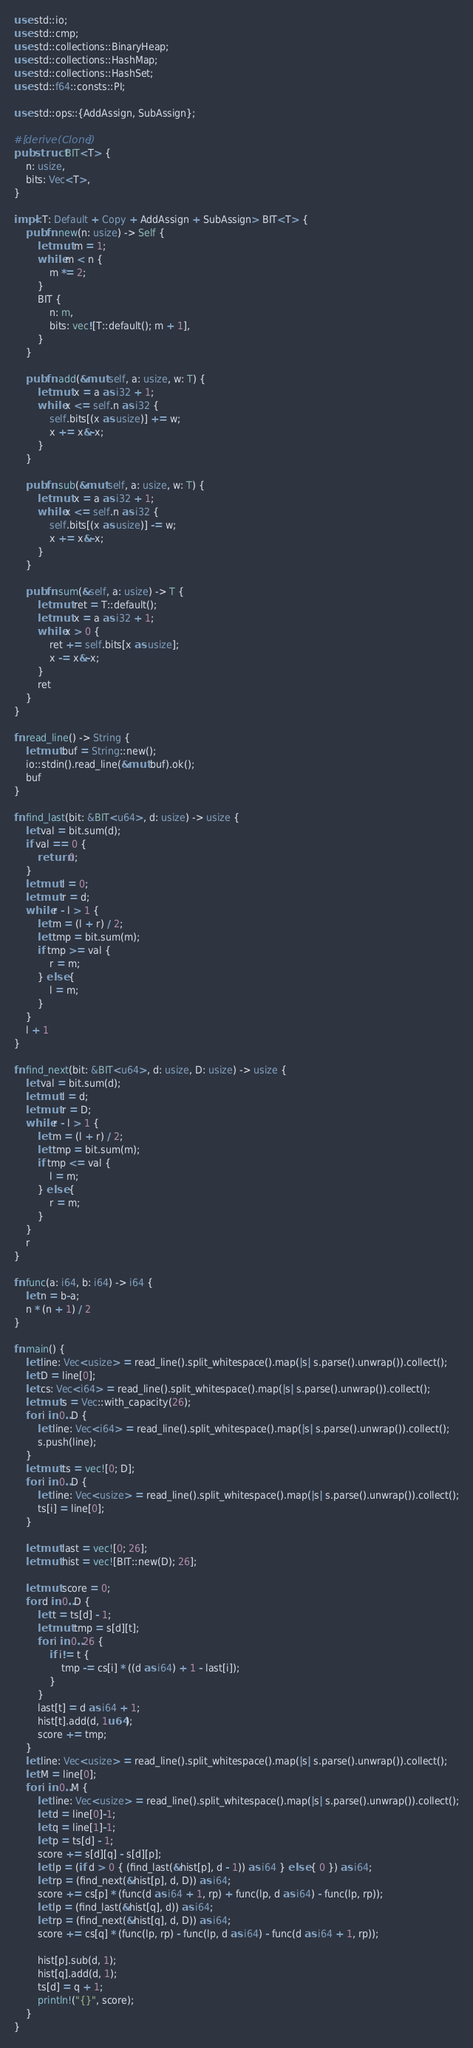<code> <loc_0><loc_0><loc_500><loc_500><_Rust_>use std::io;
use std::cmp;
use std::collections::BinaryHeap;
use std::collections::HashMap;
use std::collections::HashSet;
use std::f64::consts::PI;

use std::ops::{AddAssign, SubAssign};

#[derive(Clone)]
pub struct BIT<T> {
    n: usize,
    bits: Vec<T>,
}
 
impl<T: Default + Copy + AddAssign + SubAssign> BIT<T> {
    pub fn new(n: usize) -> Self {
        let mut m = 1;
        while m < n {
            m *= 2;
        }
        BIT {
            n: m,
            bits: vec![T::default(); m + 1],
        }
    }
 
    pub fn add(&mut self, a: usize, w: T) {
        let mut x = a as i32 + 1;
        while x <= self.n as i32 {
            self.bits[(x as usize)] += w;
            x += x&-x;
        }
    }
    
    pub fn sub(&mut self, a: usize, w: T) {
        let mut x = a as i32 + 1;
        while x <= self.n as i32 {
            self.bits[(x as usize)] -= w;
            x += x&-x;
        }
    }
 
    pub fn sum(&self, a: usize) -> T {
        let mut ret = T::default();
        let mut x = a as i32 + 1;
        while x > 0 {
            ret += self.bits[x as usize];
            x -= x&-x;
        }
        ret
    }
}

fn read_line() -> String {
    let mut buf = String::new();
    io::stdin().read_line(&mut buf).ok();
    buf
}

fn find_last(bit: &BIT<u64>, d: usize) -> usize {
    let val = bit.sum(d);
    if val == 0 {
        return 0;
    }
    let mut l = 0;
    let mut r = d;
    while r - l > 1 {
        let m = (l + r) / 2;
        let tmp = bit.sum(m);
        if tmp >= val {
            r = m;
        } else {
            l = m;
        }
    }
    l + 1
}

fn find_next(bit: &BIT<u64>, d: usize, D: usize) -> usize {
    let val = bit.sum(d);
    let mut l = d;
    let mut r = D;
    while r - l > 1 {
        let m = (l + r) / 2;
        let tmp = bit.sum(m);
        if tmp <= val {
            l = m;
        } else {
            r = m;
        }
    }
    r
}

fn func(a: i64, b: i64) -> i64 {
    let n = b-a;
    n * (n + 1) / 2
}

fn main() {
    let line: Vec<usize> = read_line().split_whitespace().map(|s| s.parse().unwrap()).collect();
    let D = line[0];
    let cs: Vec<i64> = read_line().split_whitespace().map(|s| s.parse().unwrap()).collect();
    let mut s = Vec::with_capacity(26);
    for i in 0..D {
        let line: Vec<i64> = read_line().split_whitespace().map(|s| s.parse().unwrap()).collect();
        s.push(line);
    }
    let mut ts = vec![0; D];
    for i in 0..D {
        let line: Vec<usize> = read_line().split_whitespace().map(|s| s.parse().unwrap()).collect();
        ts[i] = line[0];
    }

    let mut last = vec![0; 26];
    let mut hist = vec![BIT::new(D); 26];
    
    let mut score = 0;
    for d in 0..D {
        let t = ts[d] - 1;
        let mut tmp = s[d][t];
        for i in 0..26 {
            if i!= t {
                tmp -= cs[i] * ((d as i64) + 1 - last[i]);
            }
        }
        last[t] = d as i64 + 1;
        hist[t].add(d, 1u64);
        score += tmp;
    }
    let line: Vec<usize> = read_line().split_whitespace().map(|s| s.parse().unwrap()).collect();
    let M = line[0];
    for i in 0..M {
        let line: Vec<usize> = read_line().split_whitespace().map(|s| s.parse().unwrap()).collect();
        let d = line[0]-1;
        let q = line[1]-1;
        let p = ts[d] - 1;
        score += s[d][q] - s[d][p];
        let lp = (if d > 0 { (find_last(&hist[p], d - 1)) as i64 } else { 0 }) as i64;
        let rp = (find_next(&hist[p], d, D)) as i64;
        score += cs[p] * (func(d as i64 + 1, rp) + func(lp, d as i64) - func(lp, rp));
        let lp = (find_last(&hist[q], d)) as i64;
        let rp = (find_next(&hist[q], d, D)) as i64;
        score += cs[q] * (func(lp, rp) - func(lp, d as i64) - func(d as i64 + 1, rp));

        hist[p].sub(d, 1);
        hist[q].add(d, 1);
        ts[d] = q + 1;
        println!("{}", score);
    }
}
</code> 